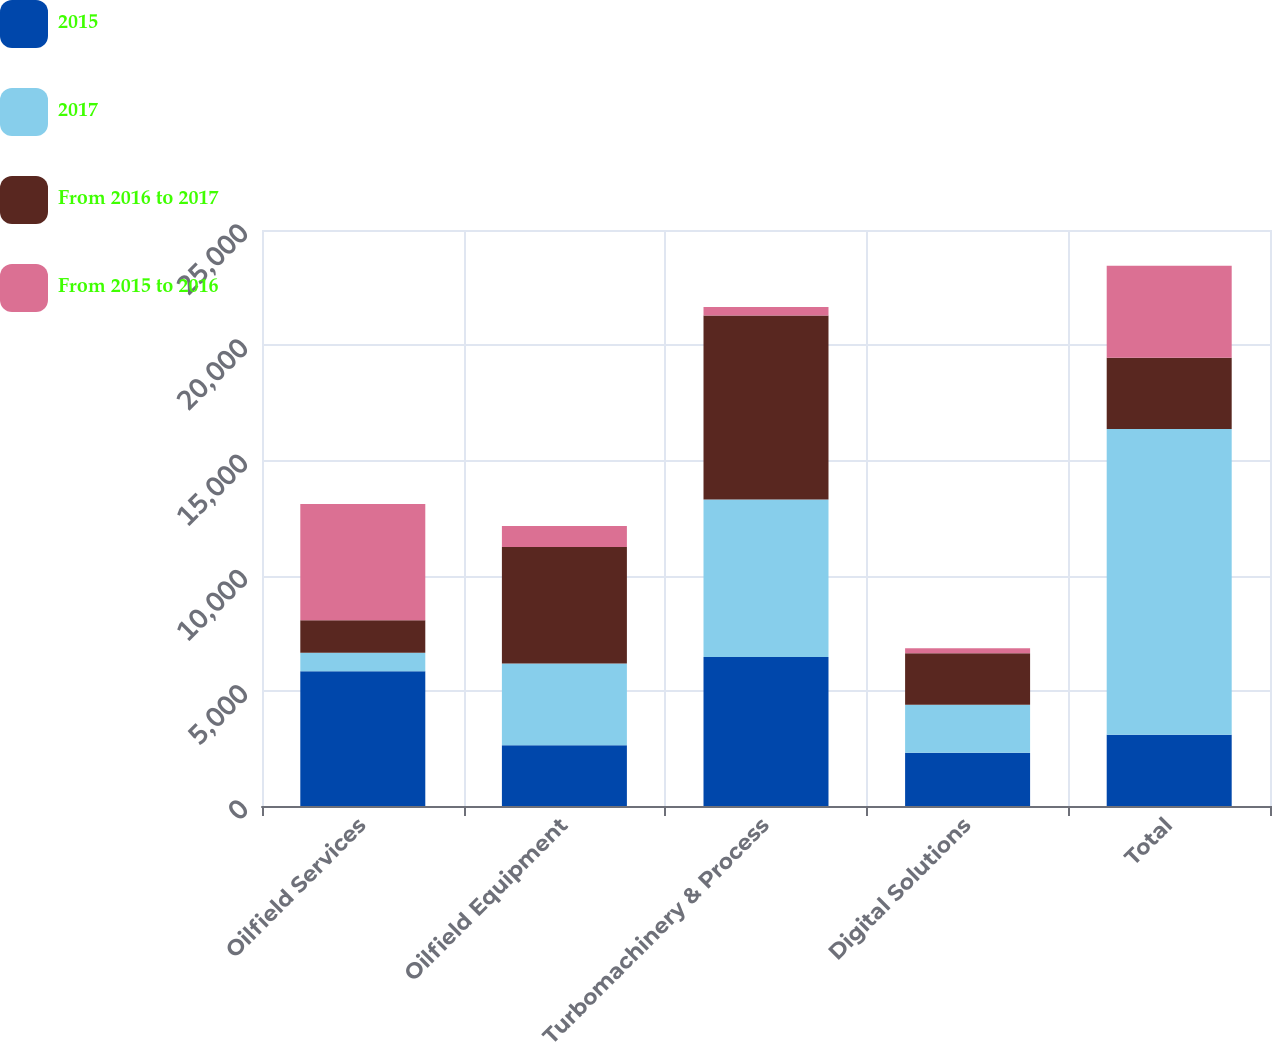Convert chart to OTSL. <chart><loc_0><loc_0><loc_500><loc_500><stacked_bar_chart><ecel><fcel>Oilfield Services<fcel>Oilfield Equipment<fcel>Turbomachinery & Process<fcel>Digital Solutions<fcel>Total<nl><fcel>2015<fcel>5851<fcel>2637<fcel>6463<fcel>2309<fcel>3092<nl><fcel>2017<fcel>799<fcel>3547<fcel>6837<fcel>2086<fcel>13269<nl><fcel>From 2016 to 2017<fcel>1411<fcel>5060<fcel>7985<fcel>2232<fcel>3092<nl><fcel>From 2015 to 2016<fcel>5052<fcel>910<fcel>374<fcel>223<fcel>3990<nl></chart> 